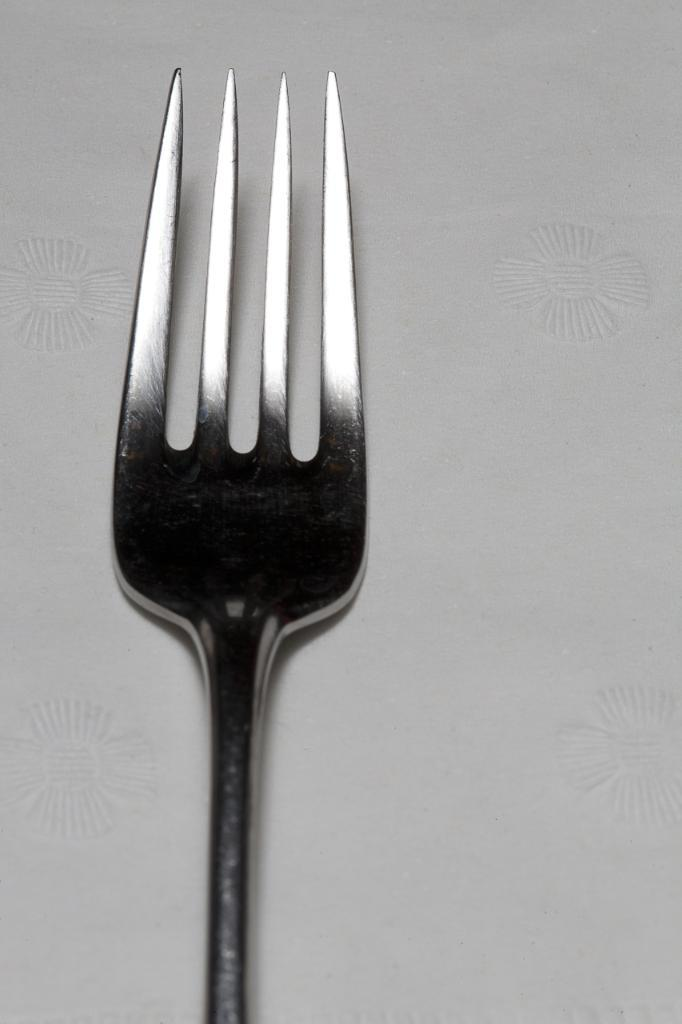What utensil is present in the image? There is a fork in the image. Where is the fork located? The fork is on a surface. What type of pancake is being served with the fork in the image? There is no pancake present in the image. 